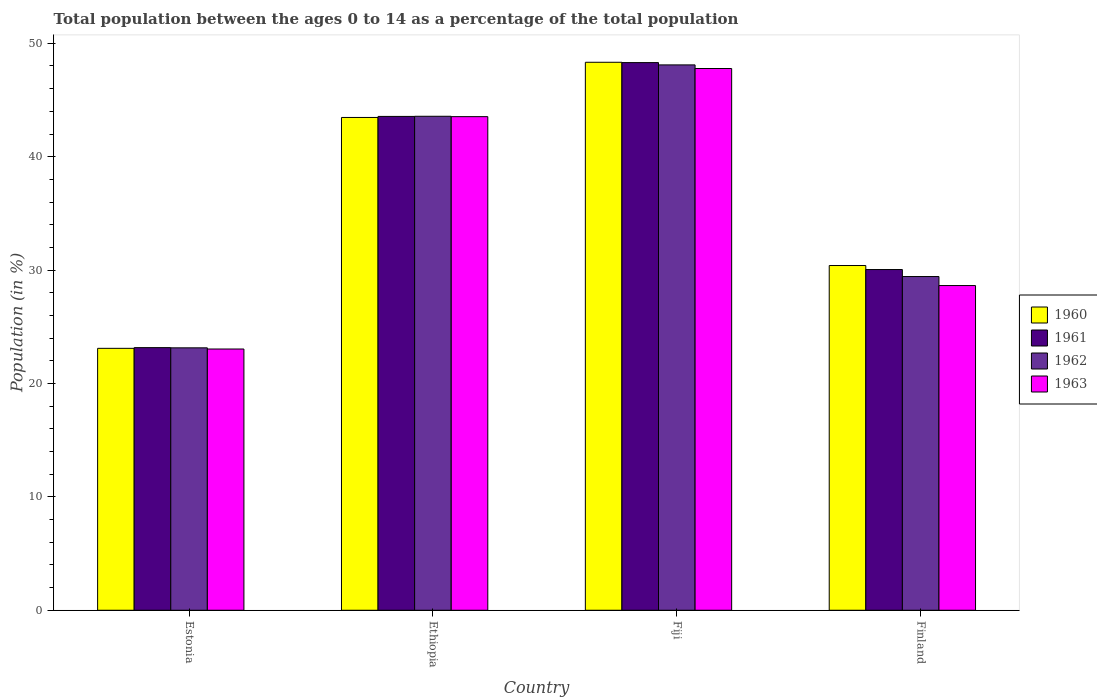How many different coloured bars are there?
Your answer should be compact. 4. How many bars are there on the 1st tick from the left?
Your answer should be very brief. 4. How many bars are there on the 4th tick from the right?
Your response must be concise. 4. What is the label of the 3rd group of bars from the left?
Provide a succinct answer. Fiji. In how many cases, is the number of bars for a given country not equal to the number of legend labels?
Your response must be concise. 0. What is the percentage of the population ages 0 to 14 in 1962 in Ethiopia?
Offer a terse response. 43.56. Across all countries, what is the maximum percentage of the population ages 0 to 14 in 1962?
Your response must be concise. 48.1. Across all countries, what is the minimum percentage of the population ages 0 to 14 in 1961?
Offer a terse response. 23.16. In which country was the percentage of the population ages 0 to 14 in 1963 maximum?
Keep it short and to the point. Fiji. In which country was the percentage of the population ages 0 to 14 in 1962 minimum?
Your answer should be very brief. Estonia. What is the total percentage of the population ages 0 to 14 in 1962 in the graph?
Ensure brevity in your answer.  144.23. What is the difference between the percentage of the population ages 0 to 14 in 1961 in Estonia and that in Ethiopia?
Your answer should be compact. -20.39. What is the difference between the percentage of the population ages 0 to 14 in 1962 in Fiji and the percentage of the population ages 0 to 14 in 1960 in Ethiopia?
Your answer should be compact. 4.64. What is the average percentage of the population ages 0 to 14 in 1963 per country?
Ensure brevity in your answer.  35.75. What is the difference between the percentage of the population ages 0 to 14 of/in 1960 and percentage of the population ages 0 to 14 of/in 1961 in Fiji?
Keep it short and to the point. 0.03. What is the ratio of the percentage of the population ages 0 to 14 in 1961 in Estonia to that in Ethiopia?
Make the answer very short. 0.53. Is the percentage of the population ages 0 to 14 in 1962 in Estonia less than that in Ethiopia?
Ensure brevity in your answer.  Yes. What is the difference between the highest and the second highest percentage of the population ages 0 to 14 in 1962?
Ensure brevity in your answer.  4.53. What is the difference between the highest and the lowest percentage of the population ages 0 to 14 in 1963?
Your response must be concise. 24.74. Is the sum of the percentage of the population ages 0 to 14 in 1962 in Fiji and Finland greater than the maximum percentage of the population ages 0 to 14 in 1961 across all countries?
Offer a terse response. Yes. Is it the case that in every country, the sum of the percentage of the population ages 0 to 14 in 1960 and percentage of the population ages 0 to 14 in 1963 is greater than the percentage of the population ages 0 to 14 in 1961?
Offer a terse response. Yes. How many bars are there?
Offer a very short reply. 16. What is the difference between two consecutive major ticks on the Y-axis?
Provide a succinct answer. 10. Does the graph contain any zero values?
Offer a terse response. No. How many legend labels are there?
Provide a succinct answer. 4. What is the title of the graph?
Provide a succinct answer. Total population between the ages 0 to 14 as a percentage of the total population. Does "1980" appear as one of the legend labels in the graph?
Give a very brief answer. No. What is the label or title of the X-axis?
Your answer should be compact. Country. What is the Population (in %) in 1960 in Estonia?
Your answer should be compact. 23.1. What is the Population (in %) in 1961 in Estonia?
Give a very brief answer. 23.16. What is the Population (in %) in 1962 in Estonia?
Keep it short and to the point. 23.14. What is the Population (in %) in 1963 in Estonia?
Give a very brief answer. 23.04. What is the Population (in %) of 1960 in Ethiopia?
Provide a succinct answer. 43.46. What is the Population (in %) of 1961 in Ethiopia?
Provide a short and direct response. 43.55. What is the Population (in %) of 1962 in Ethiopia?
Your answer should be very brief. 43.56. What is the Population (in %) of 1963 in Ethiopia?
Provide a succinct answer. 43.53. What is the Population (in %) of 1960 in Fiji?
Offer a very short reply. 48.33. What is the Population (in %) in 1961 in Fiji?
Provide a short and direct response. 48.3. What is the Population (in %) of 1962 in Fiji?
Offer a terse response. 48.1. What is the Population (in %) of 1963 in Fiji?
Your answer should be very brief. 47.78. What is the Population (in %) in 1960 in Finland?
Keep it short and to the point. 30.4. What is the Population (in %) in 1961 in Finland?
Your response must be concise. 30.05. What is the Population (in %) in 1962 in Finland?
Give a very brief answer. 29.43. What is the Population (in %) in 1963 in Finland?
Provide a succinct answer. 28.64. Across all countries, what is the maximum Population (in %) in 1960?
Offer a terse response. 48.33. Across all countries, what is the maximum Population (in %) in 1961?
Keep it short and to the point. 48.3. Across all countries, what is the maximum Population (in %) of 1962?
Your answer should be very brief. 48.1. Across all countries, what is the maximum Population (in %) in 1963?
Keep it short and to the point. 47.78. Across all countries, what is the minimum Population (in %) of 1960?
Provide a succinct answer. 23.1. Across all countries, what is the minimum Population (in %) in 1961?
Provide a short and direct response. 23.16. Across all countries, what is the minimum Population (in %) in 1962?
Your answer should be very brief. 23.14. Across all countries, what is the minimum Population (in %) of 1963?
Give a very brief answer. 23.04. What is the total Population (in %) of 1960 in the graph?
Offer a very short reply. 145.29. What is the total Population (in %) in 1961 in the graph?
Offer a terse response. 145.06. What is the total Population (in %) of 1962 in the graph?
Your answer should be very brief. 144.23. What is the total Population (in %) in 1963 in the graph?
Make the answer very short. 142.98. What is the difference between the Population (in %) of 1960 in Estonia and that in Ethiopia?
Your response must be concise. -20.36. What is the difference between the Population (in %) in 1961 in Estonia and that in Ethiopia?
Offer a very short reply. -20.39. What is the difference between the Population (in %) in 1962 in Estonia and that in Ethiopia?
Your answer should be compact. -20.42. What is the difference between the Population (in %) in 1963 in Estonia and that in Ethiopia?
Offer a very short reply. -20.49. What is the difference between the Population (in %) of 1960 in Estonia and that in Fiji?
Give a very brief answer. -25.23. What is the difference between the Population (in %) in 1961 in Estonia and that in Fiji?
Make the answer very short. -25.14. What is the difference between the Population (in %) of 1962 in Estonia and that in Fiji?
Your answer should be very brief. -24.95. What is the difference between the Population (in %) of 1963 in Estonia and that in Fiji?
Your response must be concise. -24.74. What is the difference between the Population (in %) in 1960 in Estonia and that in Finland?
Make the answer very short. -7.3. What is the difference between the Population (in %) in 1961 in Estonia and that in Finland?
Keep it short and to the point. -6.89. What is the difference between the Population (in %) in 1962 in Estonia and that in Finland?
Keep it short and to the point. -6.29. What is the difference between the Population (in %) in 1963 in Estonia and that in Finland?
Offer a very short reply. -5.6. What is the difference between the Population (in %) of 1960 in Ethiopia and that in Fiji?
Ensure brevity in your answer.  -4.87. What is the difference between the Population (in %) of 1961 in Ethiopia and that in Fiji?
Offer a very short reply. -4.75. What is the difference between the Population (in %) of 1962 in Ethiopia and that in Fiji?
Give a very brief answer. -4.53. What is the difference between the Population (in %) in 1963 in Ethiopia and that in Fiji?
Your response must be concise. -4.25. What is the difference between the Population (in %) of 1960 in Ethiopia and that in Finland?
Your answer should be very brief. 13.06. What is the difference between the Population (in %) of 1961 in Ethiopia and that in Finland?
Offer a terse response. 13.5. What is the difference between the Population (in %) in 1962 in Ethiopia and that in Finland?
Your answer should be compact. 14.13. What is the difference between the Population (in %) in 1963 in Ethiopia and that in Finland?
Ensure brevity in your answer.  14.9. What is the difference between the Population (in %) in 1960 in Fiji and that in Finland?
Offer a very short reply. 17.92. What is the difference between the Population (in %) of 1961 in Fiji and that in Finland?
Offer a terse response. 18.25. What is the difference between the Population (in %) of 1962 in Fiji and that in Finland?
Keep it short and to the point. 18.66. What is the difference between the Population (in %) of 1963 in Fiji and that in Finland?
Ensure brevity in your answer.  19.14. What is the difference between the Population (in %) of 1960 in Estonia and the Population (in %) of 1961 in Ethiopia?
Your response must be concise. -20.45. What is the difference between the Population (in %) of 1960 in Estonia and the Population (in %) of 1962 in Ethiopia?
Your answer should be compact. -20.46. What is the difference between the Population (in %) of 1960 in Estonia and the Population (in %) of 1963 in Ethiopia?
Your answer should be very brief. -20.43. What is the difference between the Population (in %) of 1961 in Estonia and the Population (in %) of 1962 in Ethiopia?
Your answer should be very brief. -20.4. What is the difference between the Population (in %) of 1961 in Estonia and the Population (in %) of 1963 in Ethiopia?
Your answer should be compact. -20.37. What is the difference between the Population (in %) in 1962 in Estonia and the Population (in %) in 1963 in Ethiopia?
Give a very brief answer. -20.39. What is the difference between the Population (in %) in 1960 in Estonia and the Population (in %) in 1961 in Fiji?
Offer a terse response. -25.2. What is the difference between the Population (in %) of 1960 in Estonia and the Population (in %) of 1962 in Fiji?
Offer a terse response. -25. What is the difference between the Population (in %) of 1960 in Estonia and the Population (in %) of 1963 in Fiji?
Provide a short and direct response. -24.68. What is the difference between the Population (in %) in 1961 in Estonia and the Population (in %) in 1962 in Fiji?
Provide a short and direct response. -24.93. What is the difference between the Population (in %) in 1961 in Estonia and the Population (in %) in 1963 in Fiji?
Make the answer very short. -24.62. What is the difference between the Population (in %) in 1962 in Estonia and the Population (in %) in 1963 in Fiji?
Provide a short and direct response. -24.63. What is the difference between the Population (in %) of 1960 in Estonia and the Population (in %) of 1961 in Finland?
Offer a terse response. -6.95. What is the difference between the Population (in %) of 1960 in Estonia and the Population (in %) of 1962 in Finland?
Your answer should be compact. -6.33. What is the difference between the Population (in %) of 1960 in Estonia and the Population (in %) of 1963 in Finland?
Provide a short and direct response. -5.54. What is the difference between the Population (in %) in 1961 in Estonia and the Population (in %) in 1962 in Finland?
Offer a terse response. -6.27. What is the difference between the Population (in %) of 1961 in Estonia and the Population (in %) of 1963 in Finland?
Offer a very short reply. -5.47. What is the difference between the Population (in %) in 1962 in Estonia and the Population (in %) in 1963 in Finland?
Keep it short and to the point. -5.49. What is the difference between the Population (in %) in 1960 in Ethiopia and the Population (in %) in 1961 in Fiji?
Provide a succinct answer. -4.84. What is the difference between the Population (in %) of 1960 in Ethiopia and the Population (in %) of 1962 in Fiji?
Keep it short and to the point. -4.64. What is the difference between the Population (in %) of 1960 in Ethiopia and the Population (in %) of 1963 in Fiji?
Keep it short and to the point. -4.32. What is the difference between the Population (in %) in 1961 in Ethiopia and the Population (in %) in 1962 in Fiji?
Your answer should be compact. -4.54. What is the difference between the Population (in %) in 1961 in Ethiopia and the Population (in %) in 1963 in Fiji?
Give a very brief answer. -4.23. What is the difference between the Population (in %) of 1962 in Ethiopia and the Population (in %) of 1963 in Fiji?
Offer a very short reply. -4.21. What is the difference between the Population (in %) of 1960 in Ethiopia and the Population (in %) of 1961 in Finland?
Offer a very short reply. 13.41. What is the difference between the Population (in %) of 1960 in Ethiopia and the Population (in %) of 1962 in Finland?
Give a very brief answer. 14.03. What is the difference between the Population (in %) of 1960 in Ethiopia and the Population (in %) of 1963 in Finland?
Your answer should be compact. 14.82. What is the difference between the Population (in %) of 1961 in Ethiopia and the Population (in %) of 1962 in Finland?
Offer a terse response. 14.12. What is the difference between the Population (in %) in 1961 in Ethiopia and the Population (in %) in 1963 in Finland?
Provide a succinct answer. 14.92. What is the difference between the Population (in %) in 1962 in Ethiopia and the Population (in %) in 1963 in Finland?
Make the answer very short. 14.93. What is the difference between the Population (in %) of 1960 in Fiji and the Population (in %) of 1961 in Finland?
Your response must be concise. 18.28. What is the difference between the Population (in %) of 1960 in Fiji and the Population (in %) of 1962 in Finland?
Provide a short and direct response. 18.9. What is the difference between the Population (in %) in 1960 in Fiji and the Population (in %) in 1963 in Finland?
Give a very brief answer. 19.69. What is the difference between the Population (in %) of 1961 in Fiji and the Population (in %) of 1962 in Finland?
Your response must be concise. 18.87. What is the difference between the Population (in %) in 1961 in Fiji and the Population (in %) in 1963 in Finland?
Ensure brevity in your answer.  19.66. What is the difference between the Population (in %) in 1962 in Fiji and the Population (in %) in 1963 in Finland?
Make the answer very short. 19.46. What is the average Population (in %) in 1960 per country?
Give a very brief answer. 36.32. What is the average Population (in %) of 1961 per country?
Offer a terse response. 36.26. What is the average Population (in %) in 1962 per country?
Keep it short and to the point. 36.06. What is the average Population (in %) of 1963 per country?
Your answer should be compact. 35.75. What is the difference between the Population (in %) of 1960 and Population (in %) of 1961 in Estonia?
Your answer should be very brief. -0.06. What is the difference between the Population (in %) of 1960 and Population (in %) of 1962 in Estonia?
Offer a terse response. -0.04. What is the difference between the Population (in %) of 1960 and Population (in %) of 1963 in Estonia?
Your answer should be very brief. 0.06. What is the difference between the Population (in %) of 1961 and Population (in %) of 1962 in Estonia?
Keep it short and to the point. 0.02. What is the difference between the Population (in %) of 1961 and Population (in %) of 1963 in Estonia?
Your response must be concise. 0.12. What is the difference between the Population (in %) in 1962 and Population (in %) in 1963 in Estonia?
Provide a succinct answer. 0.1. What is the difference between the Population (in %) of 1960 and Population (in %) of 1961 in Ethiopia?
Your answer should be very brief. -0.09. What is the difference between the Population (in %) in 1960 and Population (in %) in 1962 in Ethiopia?
Offer a terse response. -0.1. What is the difference between the Population (in %) in 1960 and Population (in %) in 1963 in Ethiopia?
Ensure brevity in your answer.  -0.07. What is the difference between the Population (in %) in 1961 and Population (in %) in 1962 in Ethiopia?
Offer a terse response. -0.01. What is the difference between the Population (in %) of 1962 and Population (in %) of 1963 in Ethiopia?
Give a very brief answer. 0.03. What is the difference between the Population (in %) of 1960 and Population (in %) of 1961 in Fiji?
Your answer should be compact. 0.03. What is the difference between the Population (in %) in 1960 and Population (in %) in 1962 in Fiji?
Provide a short and direct response. 0.23. What is the difference between the Population (in %) of 1960 and Population (in %) of 1963 in Fiji?
Give a very brief answer. 0.55. What is the difference between the Population (in %) in 1961 and Population (in %) in 1962 in Fiji?
Your answer should be compact. 0.2. What is the difference between the Population (in %) of 1961 and Population (in %) of 1963 in Fiji?
Provide a short and direct response. 0.52. What is the difference between the Population (in %) of 1962 and Population (in %) of 1963 in Fiji?
Your answer should be compact. 0.32. What is the difference between the Population (in %) in 1960 and Population (in %) in 1961 in Finland?
Keep it short and to the point. 0.35. What is the difference between the Population (in %) of 1960 and Population (in %) of 1962 in Finland?
Provide a short and direct response. 0.97. What is the difference between the Population (in %) of 1960 and Population (in %) of 1963 in Finland?
Keep it short and to the point. 1.77. What is the difference between the Population (in %) in 1961 and Population (in %) in 1962 in Finland?
Your response must be concise. 0.62. What is the difference between the Population (in %) of 1961 and Population (in %) of 1963 in Finland?
Your answer should be compact. 1.41. What is the difference between the Population (in %) of 1962 and Population (in %) of 1963 in Finland?
Your answer should be compact. 0.79. What is the ratio of the Population (in %) in 1960 in Estonia to that in Ethiopia?
Give a very brief answer. 0.53. What is the ratio of the Population (in %) of 1961 in Estonia to that in Ethiopia?
Give a very brief answer. 0.53. What is the ratio of the Population (in %) in 1962 in Estonia to that in Ethiopia?
Provide a short and direct response. 0.53. What is the ratio of the Population (in %) of 1963 in Estonia to that in Ethiopia?
Provide a short and direct response. 0.53. What is the ratio of the Population (in %) of 1960 in Estonia to that in Fiji?
Your response must be concise. 0.48. What is the ratio of the Population (in %) in 1961 in Estonia to that in Fiji?
Make the answer very short. 0.48. What is the ratio of the Population (in %) of 1962 in Estonia to that in Fiji?
Ensure brevity in your answer.  0.48. What is the ratio of the Population (in %) in 1963 in Estonia to that in Fiji?
Provide a short and direct response. 0.48. What is the ratio of the Population (in %) of 1960 in Estonia to that in Finland?
Your response must be concise. 0.76. What is the ratio of the Population (in %) in 1961 in Estonia to that in Finland?
Give a very brief answer. 0.77. What is the ratio of the Population (in %) in 1962 in Estonia to that in Finland?
Make the answer very short. 0.79. What is the ratio of the Population (in %) of 1963 in Estonia to that in Finland?
Make the answer very short. 0.8. What is the ratio of the Population (in %) in 1960 in Ethiopia to that in Fiji?
Provide a short and direct response. 0.9. What is the ratio of the Population (in %) of 1961 in Ethiopia to that in Fiji?
Ensure brevity in your answer.  0.9. What is the ratio of the Population (in %) of 1962 in Ethiopia to that in Fiji?
Provide a succinct answer. 0.91. What is the ratio of the Population (in %) of 1963 in Ethiopia to that in Fiji?
Your answer should be very brief. 0.91. What is the ratio of the Population (in %) in 1960 in Ethiopia to that in Finland?
Your response must be concise. 1.43. What is the ratio of the Population (in %) in 1961 in Ethiopia to that in Finland?
Provide a succinct answer. 1.45. What is the ratio of the Population (in %) in 1962 in Ethiopia to that in Finland?
Give a very brief answer. 1.48. What is the ratio of the Population (in %) of 1963 in Ethiopia to that in Finland?
Make the answer very short. 1.52. What is the ratio of the Population (in %) in 1960 in Fiji to that in Finland?
Offer a very short reply. 1.59. What is the ratio of the Population (in %) in 1961 in Fiji to that in Finland?
Ensure brevity in your answer.  1.61. What is the ratio of the Population (in %) of 1962 in Fiji to that in Finland?
Your response must be concise. 1.63. What is the ratio of the Population (in %) of 1963 in Fiji to that in Finland?
Your answer should be very brief. 1.67. What is the difference between the highest and the second highest Population (in %) in 1960?
Your response must be concise. 4.87. What is the difference between the highest and the second highest Population (in %) in 1961?
Make the answer very short. 4.75. What is the difference between the highest and the second highest Population (in %) of 1962?
Offer a terse response. 4.53. What is the difference between the highest and the second highest Population (in %) of 1963?
Ensure brevity in your answer.  4.25. What is the difference between the highest and the lowest Population (in %) in 1960?
Give a very brief answer. 25.23. What is the difference between the highest and the lowest Population (in %) of 1961?
Provide a short and direct response. 25.14. What is the difference between the highest and the lowest Population (in %) of 1962?
Offer a terse response. 24.95. What is the difference between the highest and the lowest Population (in %) of 1963?
Provide a short and direct response. 24.74. 